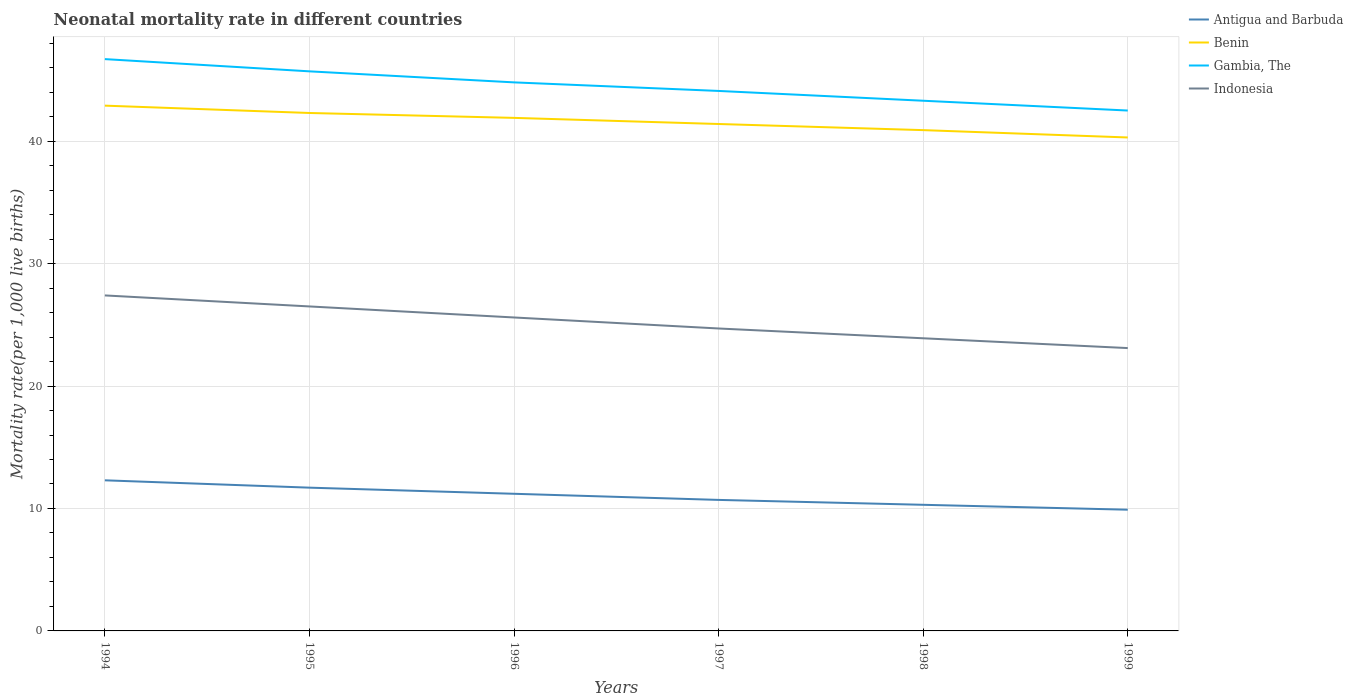Does the line corresponding to Benin intersect with the line corresponding to Antigua and Barbuda?
Your response must be concise. No. Is the number of lines equal to the number of legend labels?
Make the answer very short. Yes. Across all years, what is the maximum neonatal mortality rate in Gambia, The?
Offer a very short reply. 42.5. What is the total neonatal mortality rate in Antigua and Barbuda in the graph?
Ensure brevity in your answer.  1.3. What is the difference between the highest and the second highest neonatal mortality rate in Antigua and Barbuda?
Offer a very short reply. 2.4. How many lines are there?
Your answer should be compact. 4. How many years are there in the graph?
Give a very brief answer. 6. Does the graph contain any zero values?
Provide a succinct answer. No. Where does the legend appear in the graph?
Provide a short and direct response. Top right. How are the legend labels stacked?
Your response must be concise. Vertical. What is the title of the graph?
Offer a terse response. Neonatal mortality rate in different countries. What is the label or title of the Y-axis?
Your answer should be very brief. Mortality rate(per 1,0 live births). What is the Mortality rate(per 1,000 live births) in Antigua and Barbuda in 1994?
Keep it short and to the point. 12.3. What is the Mortality rate(per 1,000 live births) in Benin in 1994?
Make the answer very short. 42.9. What is the Mortality rate(per 1,000 live births) of Gambia, The in 1994?
Offer a terse response. 46.7. What is the Mortality rate(per 1,000 live births) in Indonesia in 1994?
Your response must be concise. 27.4. What is the Mortality rate(per 1,000 live births) of Antigua and Barbuda in 1995?
Provide a succinct answer. 11.7. What is the Mortality rate(per 1,000 live births) in Benin in 1995?
Provide a succinct answer. 42.3. What is the Mortality rate(per 1,000 live births) of Gambia, The in 1995?
Keep it short and to the point. 45.7. What is the Mortality rate(per 1,000 live births) of Benin in 1996?
Your answer should be compact. 41.9. What is the Mortality rate(per 1,000 live births) of Gambia, The in 1996?
Offer a very short reply. 44.8. What is the Mortality rate(per 1,000 live births) of Indonesia in 1996?
Provide a succinct answer. 25.6. What is the Mortality rate(per 1,000 live births) in Antigua and Barbuda in 1997?
Offer a terse response. 10.7. What is the Mortality rate(per 1,000 live births) of Benin in 1997?
Provide a short and direct response. 41.4. What is the Mortality rate(per 1,000 live births) of Gambia, The in 1997?
Your answer should be very brief. 44.1. What is the Mortality rate(per 1,000 live births) in Indonesia in 1997?
Your answer should be very brief. 24.7. What is the Mortality rate(per 1,000 live births) in Benin in 1998?
Your answer should be compact. 40.9. What is the Mortality rate(per 1,000 live births) in Gambia, The in 1998?
Your answer should be compact. 43.3. What is the Mortality rate(per 1,000 live births) in Indonesia in 1998?
Keep it short and to the point. 23.9. What is the Mortality rate(per 1,000 live births) in Benin in 1999?
Your response must be concise. 40.3. What is the Mortality rate(per 1,000 live births) in Gambia, The in 1999?
Your answer should be compact. 42.5. What is the Mortality rate(per 1,000 live births) in Indonesia in 1999?
Make the answer very short. 23.1. Across all years, what is the maximum Mortality rate(per 1,000 live births) of Benin?
Provide a succinct answer. 42.9. Across all years, what is the maximum Mortality rate(per 1,000 live births) of Gambia, The?
Offer a terse response. 46.7. Across all years, what is the maximum Mortality rate(per 1,000 live births) of Indonesia?
Give a very brief answer. 27.4. Across all years, what is the minimum Mortality rate(per 1,000 live births) in Benin?
Offer a terse response. 40.3. Across all years, what is the minimum Mortality rate(per 1,000 live births) of Gambia, The?
Ensure brevity in your answer.  42.5. Across all years, what is the minimum Mortality rate(per 1,000 live births) in Indonesia?
Provide a short and direct response. 23.1. What is the total Mortality rate(per 1,000 live births) of Antigua and Barbuda in the graph?
Make the answer very short. 66.1. What is the total Mortality rate(per 1,000 live births) of Benin in the graph?
Make the answer very short. 249.7. What is the total Mortality rate(per 1,000 live births) of Gambia, The in the graph?
Offer a terse response. 267.1. What is the total Mortality rate(per 1,000 live births) of Indonesia in the graph?
Ensure brevity in your answer.  151.2. What is the difference between the Mortality rate(per 1,000 live births) in Benin in 1994 and that in 1995?
Ensure brevity in your answer.  0.6. What is the difference between the Mortality rate(per 1,000 live births) in Indonesia in 1994 and that in 1996?
Your answer should be very brief. 1.8. What is the difference between the Mortality rate(per 1,000 live births) in Indonesia in 1994 and that in 1997?
Your response must be concise. 2.7. What is the difference between the Mortality rate(per 1,000 live births) in Antigua and Barbuda in 1994 and that in 1998?
Your answer should be very brief. 2. What is the difference between the Mortality rate(per 1,000 live births) in Indonesia in 1994 and that in 1998?
Keep it short and to the point. 3.5. What is the difference between the Mortality rate(per 1,000 live births) in Benin in 1994 and that in 1999?
Offer a terse response. 2.6. What is the difference between the Mortality rate(per 1,000 live births) in Gambia, The in 1994 and that in 1999?
Ensure brevity in your answer.  4.2. What is the difference between the Mortality rate(per 1,000 live births) of Benin in 1995 and that in 1996?
Provide a short and direct response. 0.4. What is the difference between the Mortality rate(per 1,000 live births) in Gambia, The in 1995 and that in 1996?
Your answer should be compact. 0.9. What is the difference between the Mortality rate(per 1,000 live births) in Antigua and Barbuda in 1995 and that in 1997?
Keep it short and to the point. 1. What is the difference between the Mortality rate(per 1,000 live births) in Indonesia in 1995 and that in 1998?
Offer a terse response. 2.6. What is the difference between the Mortality rate(per 1,000 live births) in Gambia, The in 1995 and that in 1999?
Give a very brief answer. 3.2. What is the difference between the Mortality rate(per 1,000 live births) in Indonesia in 1995 and that in 1999?
Provide a short and direct response. 3.4. What is the difference between the Mortality rate(per 1,000 live births) in Antigua and Barbuda in 1996 and that in 1997?
Your response must be concise. 0.5. What is the difference between the Mortality rate(per 1,000 live births) of Benin in 1996 and that in 1997?
Make the answer very short. 0.5. What is the difference between the Mortality rate(per 1,000 live births) in Indonesia in 1996 and that in 1997?
Give a very brief answer. 0.9. What is the difference between the Mortality rate(per 1,000 live births) in Antigua and Barbuda in 1996 and that in 1998?
Offer a terse response. 0.9. What is the difference between the Mortality rate(per 1,000 live births) in Benin in 1996 and that in 1998?
Your answer should be compact. 1. What is the difference between the Mortality rate(per 1,000 live births) in Indonesia in 1996 and that in 1998?
Provide a short and direct response. 1.7. What is the difference between the Mortality rate(per 1,000 live births) of Benin in 1996 and that in 1999?
Give a very brief answer. 1.6. What is the difference between the Mortality rate(per 1,000 live births) in Indonesia in 1996 and that in 1999?
Offer a terse response. 2.5. What is the difference between the Mortality rate(per 1,000 live births) in Indonesia in 1997 and that in 1998?
Make the answer very short. 0.8. What is the difference between the Mortality rate(per 1,000 live births) of Antigua and Barbuda in 1997 and that in 1999?
Make the answer very short. 0.8. What is the difference between the Mortality rate(per 1,000 live births) of Benin in 1997 and that in 1999?
Ensure brevity in your answer.  1.1. What is the difference between the Mortality rate(per 1,000 live births) in Gambia, The in 1997 and that in 1999?
Provide a succinct answer. 1.6. What is the difference between the Mortality rate(per 1,000 live births) of Indonesia in 1997 and that in 1999?
Offer a terse response. 1.6. What is the difference between the Mortality rate(per 1,000 live births) in Benin in 1998 and that in 1999?
Provide a short and direct response. 0.6. What is the difference between the Mortality rate(per 1,000 live births) of Gambia, The in 1998 and that in 1999?
Offer a very short reply. 0.8. What is the difference between the Mortality rate(per 1,000 live births) in Indonesia in 1998 and that in 1999?
Your answer should be very brief. 0.8. What is the difference between the Mortality rate(per 1,000 live births) of Antigua and Barbuda in 1994 and the Mortality rate(per 1,000 live births) of Benin in 1995?
Offer a very short reply. -30. What is the difference between the Mortality rate(per 1,000 live births) in Antigua and Barbuda in 1994 and the Mortality rate(per 1,000 live births) in Gambia, The in 1995?
Your answer should be very brief. -33.4. What is the difference between the Mortality rate(per 1,000 live births) of Antigua and Barbuda in 1994 and the Mortality rate(per 1,000 live births) of Indonesia in 1995?
Provide a short and direct response. -14.2. What is the difference between the Mortality rate(per 1,000 live births) of Benin in 1994 and the Mortality rate(per 1,000 live births) of Indonesia in 1995?
Your response must be concise. 16.4. What is the difference between the Mortality rate(per 1,000 live births) in Gambia, The in 1994 and the Mortality rate(per 1,000 live births) in Indonesia in 1995?
Your response must be concise. 20.2. What is the difference between the Mortality rate(per 1,000 live births) of Antigua and Barbuda in 1994 and the Mortality rate(per 1,000 live births) of Benin in 1996?
Make the answer very short. -29.6. What is the difference between the Mortality rate(per 1,000 live births) in Antigua and Barbuda in 1994 and the Mortality rate(per 1,000 live births) in Gambia, The in 1996?
Offer a very short reply. -32.5. What is the difference between the Mortality rate(per 1,000 live births) of Antigua and Barbuda in 1994 and the Mortality rate(per 1,000 live births) of Indonesia in 1996?
Your response must be concise. -13.3. What is the difference between the Mortality rate(per 1,000 live births) of Benin in 1994 and the Mortality rate(per 1,000 live births) of Gambia, The in 1996?
Your answer should be very brief. -1.9. What is the difference between the Mortality rate(per 1,000 live births) in Benin in 1994 and the Mortality rate(per 1,000 live births) in Indonesia in 1996?
Provide a succinct answer. 17.3. What is the difference between the Mortality rate(per 1,000 live births) in Gambia, The in 1994 and the Mortality rate(per 1,000 live births) in Indonesia in 1996?
Your answer should be very brief. 21.1. What is the difference between the Mortality rate(per 1,000 live births) of Antigua and Barbuda in 1994 and the Mortality rate(per 1,000 live births) of Benin in 1997?
Offer a very short reply. -29.1. What is the difference between the Mortality rate(per 1,000 live births) in Antigua and Barbuda in 1994 and the Mortality rate(per 1,000 live births) in Gambia, The in 1997?
Offer a terse response. -31.8. What is the difference between the Mortality rate(per 1,000 live births) in Antigua and Barbuda in 1994 and the Mortality rate(per 1,000 live births) in Indonesia in 1997?
Your answer should be very brief. -12.4. What is the difference between the Mortality rate(per 1,000 live births) of Benin in 1994 and the Mortality rate(per 1,000 live births) of Indonesia in 1997?
Provide a short and direct response. 18.2. What is the difference between the Mortality rate(per 1,000 live births) in Antigua and Barbuda in 1994 and the Mortality rate(per 1,000 live births) in Benin in 1998?
Make the answer very short. -28.6. What is the difference between the Mortality rate(per 1,000 live births) of Antigua and Barbuda in 1994 and the Mortality rate(per 1,000 live births) of Gambia, The in 1998?
Offer a very short reply. -31. What is the difference between the Mortality rate(per 1,000 live births) of Gambia, The in 1994 and the Mortality rate(per 1,000 live births) of Indonesia in 1998?
Keep it short and to the point. 22.8. What is the difference between the Mortality rate(per 1,000 live births) in Antigua and Barbuda in 1994 and the Mortality rate(per 1,000 live births) in Benin in 1999?
Ensure brevity in your answer.  -28. What is the difference between the Mortality rate(per 1,000 live births) in Antigua and Barbuda in 1994 and the Mortality rate(per 1,000 live births) in Gambia, The in 1999?
Your answer should be compact. -30.2. What is the difference between the Mortality rate(per 1,000 live births) of Antigua and Barbuda in 1994 and the Mortality rate(per 1,000 live births) of Indonesia in 1999?
Your answer should be compact. -10.8. What is the difference between the Mortality rate(per 1,000 live births) in Benin in 1994 and the Mortality rate(per 1,000 live births) in Indonesia in 1999?
Make the answer very short. 19.8. What is the difference between the Mortality rate(per 1,000 live births) in Gambia, The in 1994 and the Mortality rate(per 1,000 live births) in Indonesia in 1999?
Provide a short and direct response. 23.6. What is the difference between the Mortality rate(per 1,000 live births) in Antigua and Barbuda in 1995 and the Mortality rate(per 1,000 live births) in Benin in 1996?
Your response must be concise. -30.2. What is the difference between the Mortality rate(per 1,000 live births) in Antigua and Barbuda in 1995 and the Mortality rate(per 1,000 live births) in Gambia, The in 1996?
Ensure brevity in your answer.  -33.1. What is the difference between the Mortality rate(per 1,000 live births) in Benin in 1995 and the Mortality rate(per 1,000 live births) in Indonesia in 1996?
Ensure brevity in your answer.  16.7. What is the difference between the Mortality rate(per 1,000 live births) in Gambia, The in 1995 and the Mortality rate(per 1,000 live births) in Indonesia in 1996?
Offer a terse response. 20.1. What is the difference between the Mortality rate(per 1,000 live births) of Antigua and Barbuda in 1995 and the Mortality rate(per 1,000 live births) of Benin in 1997?
Ensure brevity in your answer.  -29.7. What is the difference between the Mortality rate(per 1,000 live births) of Antigua and Barbuda in 1995 and the Mortality rate(per 1,000 live births) of Gambia, The in 1997?
Your answer should be very brief. -32.4. What is the difference between the Mortality rate(per 1,000 live births) of Antigua and Barbuda in 1995 and the Mortality rate(per 1,000 live births) of Indonesia in 1997?
Offer a very short reply. -13. What is the difference between the Mortality rate(per 1,000 live births) in Benin in 1995 and the Mortality rate(per 1,000 live births) in Gambia, The in 1997?
Your response must be concise. -1.8. What is the difference between the Mortality rate(per 1,000 live births) in Benin in 1995 and the Mortality rate(per 1,000 live births) in Indonesia in 1997?
Your answer should be very brief. 17.6. What is the difference between the Mortality rate(per 1,000 live births) in Antigua and Barbuda in 1995 and the Mortality rate(per 1,000 live births) in Benin in 1998?
Provide a succinct answer. -29.2. What is the difference between the Mortality rate(per 1,000 live births) of Antigua and Barbuda in 1995 and the Mortality rate(per 1,000 live births) of Gambia, The in 1998?
Ensure brevity in your answer.  -31.6. What is the difference between the Mortality rate(per 1,000 live births) in Benin in 1995 and the Mortality rate(per 1,000 live births) in Gambia, The in 1998?
Your answer should be very brief. -1. What is the difference between the Mortality rate(per 1,000 live births) in Gambia, The in 1995 and the Mortality rate(per 1,000 live births) in Indonesia in 1998?
Provide a short and direct response. 21.8. What is the difference between the Mortality rate(per 1,000 live births) of Antigua and Barbuda in 1995 and the Mortality rate(per 1,000 live births) of Benin in 1999?
Provide a succinct answer. -28.6. What is the difference between the Mortality rate(per 1,000 live births) in Antigua and Barbuda in 1995 and the Mortality rate(per 1,000 live births) in Gambia, The in 1999?
Make the answer very short. -30.8. What is the difference between the Mortality rate(per 1,000 live births) in Antigua and Barbuda in 1995 and the Mortality rate(per 1,000 live births) in Indonesia in 1999?
Offer a terse response. -11.4. What is the difference between the Mortality rate(per 1,000 live births) in Benin in 1995 and the Mortality rate(per 1,000 live births) in Gambia, The in 1999?
Provide a succinct answer. -0.2. What is the difference between the Mortality rate(per 1,000 live births) in Gambia, The in 1995 and the Mortality rate(per 1,000 live births) in Indonesia in 1999?
Offer a very short reply. 22.6. What is the difference between the Mortality rate(per 1,000 live births) in Antigua and Barbuda in 1996 and the Mortality rate(per 1,000 live births) in Benin in 1997?
Offer a very short reply. -30.2. What is the difference between the Mortality rate(per 1,000 live births) of Antigua and Barbuda in 1996 and the Mortality rate(per 1,000 live births) of Gambia, The in 1997?
Offer a very short reply. -32.9. What is the difference between the Mortality rate(per 1,000 live births) in Benin in 1996 and the Mortality rate(per 1,000 live births) in Indonesia in 1997?
Provide a succinct answer. 17.2. What is the difference between the Mortality rate(per 1,000 live births) of Gambia, The in 1996 and the Mortality rate(per 1,000 live births) of Indonesia in 1997?
Your answer should be very brief. 20.1. What is the difference between the Mortality rate(per 1,000 live births) of Antigua and Barbuda in 1996 and the Mortality rate(per 1,000 live births) of Benin in 1998?
Make the answer very short. -29.7. What is the difference between the Mortality rate(per 1,000 live births) of Antigua and Barbuda in 1996 and the Mortality rate(per 1,000 live births) of Gambia, The in 1998?
Give a very brief answer. -32.1. What is the difference between the Mortality rate(per 1,000 live births) of Antigua and Barbuda in 1996 and the Mortality rate(per 1,000 live births) of Indonesia in 1998?
Offer a terse response. -12.7. What is the difference between the Mortality rate(per 1,000 live births) of Benin in 1996 and the Mortality rate(per 1,000 live births) of Gambia, The in 1998?
Your answer should be very brief. -1.4. What is the difference between the Mortality rate(per 1,000 live births) of Benin in 1996 and the Mortality rate(per 1,000 live births) of Indonesia in 1998?
Your response must be concise. 18. What is the difference between the Mortality rate(per 1,000 live births) of Gambia, The in 1996 and the Mortality rate(per 1,000 live births) of Indonesia in 1998?
Your answer should be compact. 20.9. What is the difference between the Mortality rate(per 1,000 live births) in Antigua and Barbuda in 1996 and the Mortality rate(per 1,000 live births) in Benin in 1999?
Ensure brevity in your answer.  -29.1. What is the difference between the Mortality rate(per 1,000 live births) of Antigua and Barbuda in 1996 and the Mortality rate(per 1,000 live births) of Gambia, The in 1999?
Your answer should be very brief. -31.3. What is the difference between the Mortality rate(per 1,000 live births) of Antigua and Barbuda in 1996 and the Mortality rate(per 1,000 live births) of Indonesia in 1999?
Provide a succinct answer. -11.9. What is the difference between the Mortality rate(per 1,000 live births) of Gambia, The in 1996 and the Mortality rate(per 1,000 live births) of Indonesia in 1999?
Keep it short and to the point. 21.7. What is the difference between the Mortality rate(per 1,000 live births) of Antigua and Barbuda in 1997 and the Mortality rate(per 1,000 live births) of Benin in 1998?
Provide a succinct answer. -30.2. What is the difference between the Mortality rate(per 1,000 live births) in Antigua and Barbuda in 1997 and the Mortality rate(per 1,000 live births) in Gambia, The in 1998?
Your response must be concise. -32.6. What is the difference between the Mortality rate(per 1,000 live births) in Antigua and Barbuda in 1997 and the Mortality rate(per 1,000 live births) in Indonesia in 1998?
Your response must be concise. -13.2. What is the difference between the Mortality rate(per 1,000 live births) of Benin in 1997 and the Mortality rate(per 1,000 live births) of Indonesia in 1998?
Your response must be concise. 17.5. What is the difference between the Mortality rate(per 1,000 live births) in Gambia, The in 1997 and the Mortality rate(per 1,000 live births) in Indonesia in 1998?
Offer a very short reply. 20.2. What is the difference between the Mortality rate(per 1,000 live births) in Antigua and Barbuda in 1997 and the Mortality rate(per 1,000 live births) in Benin in 1999?
Provide a succinct answer. -29.6. What is the difference between the Mortality rate(per 1,000 live births) of Antigua and Barbuda in 1997 and the Mortality rate(per 1,000 live births) of Gambia, The in 1999?
Give a very brief answer. -31.8. What is the difference between the Mortality rate(per 1,000 live births) in Benin in 1997 and the Mortality rate(per 1,000 live births) in Gambia, The in 1999?
Your response must be concise. -1.1. What is the difference between the Mortality rate(per 1,000 live births) in Benin in 1997 and the Mortality rate(per 1,000 live births) in Indonesia in 1999?
Ensure brevity in your answer.  18.3. What is the difference between the Mortality rate(per 1,000 live births) of Gambia, The in 1997 and the Mortality rate(per 1,000 live births) of Indonesia in 1999?
Provide a succinct answer. 21. What is the difference between the Mortality rate(per 1,000 live births) of Antigua and Barbuda in 1998 and the Mortality rate(per 1,000 live births) of Benin in 1999?
Your answer should be very brief. -30. What is the difference between the Mortality rate(per 1,000 live births) of Antigua and Barbuda in 1998 and the Mortality rate(per 1,000 live births) of Gambia, The in 1999?
Make the answer very short. -32.2. What is the difference between the Mortality rate(per 1,000 live births) of Antigua and Barbuda in 1998 and the Mortality rate(per 1,000 live births) of Indonesia in 1999?
Provide a succinct answer. -12.8. What is the difference between the Mortality rate(per 1,000 live births) of Benin in 1998 and the Mortality rate(per 1,000 live births) of Indonesia in 1999?
Give a very brief answer. 17.8. What is the difference between the Mortality rate(per 1,000 live births) of Gambia, The in 1998 and the Mortality rate(per 1,000 live births) of Indonesia in 1999?
Your answer should be compact. 20.2. What is the average Mortality rate(per 1,000 live births) of Antigua and Barbuda per year?
Provide a short and direct response. 11.02. What is the average Mortality rate(per 1,000 live births) in Benin per year?
Offer a terse response. 41.62. What is the average Mortality rate(per 1,000 live births) of Gambia, The per year?
Your response must be concise. 44.52. What is the average Mortality rate(per 1,000 live births) of Indonesia per year?
Ensure brevity in your answer.  25.2. In the year 1994, what is the difference between the Mortality rate(per 1,000 live births) in Antigua and Barbuda and Mortality rate(per 1,000 live births) in Benin?
Give a very brief answer. -30.6. In the year 1994, what is the difference between the Mortality rate(per 1,000 live births) in Antigua and Barbuda and Mortality rate(per 1,000 live births) in Gambia, The?
Offer a terse response. -34.4. In the year 1994, what is the difference between the Mortality rate(per 1,000 live births) of Antigua and Barbuda and Mortality rate(per 1,000 live births) of Indonesia?
Ensure brevity in your answer.  -15.1. In the year 1994, what is the difference between the Mortality rate(per 1,000 live births) of Benin and Mortality rate(per 1,000 live births) of Indonesia?
Provide a short and direct response. 15.5. In the year 1994, what is the difference between the Mortality rate(per 1,000 live births) in Gambia, The and Mortality rate(per 1,000 live births) in Indonesia?
Offer a very short reply. 19.3. In the year 1995, what is the difference between the Mortality rate(per 1,000 live births) of Antigua and Barbuda and Mortality rate(per 1,000 live births) of Benin?
Make the answer very short. -30.6. In the year 1995, what is the difference between the Mortality rate(per 1,000 live births) of Antigua and Barbuda and Mortality rate(per 1,000 live births) of Gambia, The?
Provide a short and direct response. -34. In the year 1995, what is the difference between the Mortality rate(per 1,000 live births) of Antigua and Barbuda and Mortality rate(per 1,000 live births) of Indonesia?
Offer a very short reply. -14.8. In the year 1995, what is the difference between the Mortality rate(per 1,000 live births) of Gambia, The and Mortality rate(per 1,000 live births) of Indonesia?
Ensure brevity in your answer.  19.2. In the year 1996, what is the difference between the Mortality rate(per 1,000 live births) in Antigua and Barbuda and Mortality rate(per 1,000 live births) in Benin?
Offer a terse response. -30.7. In the year 1996, what is the difference between the Mortality rate(per 1,000 live births) of Antigua and Barbuda and Mortality rate(per 1,000 live births) of Gambia, The?
Offer a very short reply. -33.6. In the year 1996, what is the difference between the Mortality rate(per 1,000 live births) in Antigua and Barbuda and Mortality rate(per 1,000 live births) in Indonesia?
Ensure brevity in your answer.  -14.4. In the year 1996, what is the difference between the Mortality rate(per 1,000 live births) in Benin and Mortality rate(per 1,000 live births) in Gambia, The?
Your response must be concise. -2.9. In the year 1996, what is the difference between the Mortality rate(per 1,000 live births) in Benin and Mortality rate(per 1,000 live births) in Indonesia?
Make the answer very short. 16.3. In the year 1997, what is the difference between the Mortality rate(per 1,000 live births) of Antigua and Barbuda and Mortality rate(per 1,000 live births) of Benin?
Offer a very short reply. -30.7. In the year 1997, what is the difference between the Mortality rate(per 1,000 live births) in Antigua and Barbuda and Mortality rate(per 1,000 live births) in Gambia, The?
Offer a very short reply. -33.4. In the year 1997, what is the difference between the Mortality rate(per 1,000 live births) in Benin and Mortality rate(per 1,000 live births) in Gambia, The?
Offer a very short reply. -2.7. In the year 1998, what is the difference between the Mortality rate(per 1,000 live births) of Antigua and Barbuda and Mortality rate(per 1,000 live births) of Benin?
Offer a very short reply. -30.6. In the year 1998, what is the difference between the Mortality rate(per 1,000 live births) of Antigua and Barbuda and Mortality rate(per 1,000 live births) of Gambia, The?
Make the answer very short. -33. In the year 1998, what is the difference between the Mortality rate(per 1,000 live births) of Antigua and Barbuda and Mortality rate(per 1,000 live births) of Indonesia?
Ensure brevity in your answer.  -13.6. In the year 1999, what is the difference between the Mortality rate(per 1,000 live births) of Antigua and Barbuda and Mortality rate(per 1,000 live births) of Benin?
Offer a terse response. -30.4. In the year 1999, what is the difference between the Mortality rate(per 1,000 live births) in Antigua and Barbuda and Mortality rate(per 1,000 live births) in Gambia, The?
Give a very brief answer. -32.6. In the year 1999, what is the difference between the Mortality rate(per 1,000 live births) of Antigua and Barbuda and Mortality rate(per 1,000 live births) of Indonesia?
Keep it short and to the point. -13.2. In the year 1999, what is the difference between the Mortality rate(per 1,000 live births) in Benin and Mortality rate(per 1,000 live births) in Gambia, The?
Offer a terse response. -2.2. In the year 1999, what is the difference between the Mortality rate(per 1,000 live births) of Gambia, The and Mortality rate(per 1,000 live births) of Indonesia?
Provide a succinct answer. 19.4. What is the ratio of the Mortality rate(per 1,000 live births) of Antigua and Barbuda in 1994 to that in 1995?
Your response must be concise. 1.05. What is the ratio of the Mortality rate(per 1,000 live births) of Benin in 1994 to that in 1995?
Your answer should be very brief. 1.01. What is the ratio of the Mortality rate(per 1,000 live births) in Gambia, The in 1994 to that in 1995?
Provide a succinct answer. 1.02. What is the ratio of the Mortality rate(per 1,000 live births) of Indonesia in 1994 to that in 1995?
Provide a succinct answer. 1.03. What is the ratio of the Mortality rate(per 1,000 live births) of Antigua and Barbuda in 1994 to that in 1996?
Your answer should be compact. 1.1. What is the ratio of the Mortality rate(per 1,000 live births) of Benin in 1994 to that in 1996?
Your response must be concise. 1.02. What is the ratio of the Mortality rate(per 1,000 live births) of Gambia, The in 1994 to that in 1996?
Offer a very short reply. 1.04. What is the ratio of the Mortality rate(per 1,000 live births) in Indonesia in 1994 to that in 1996?
Provide a succinct answer. 1.07. What is the ratio of the Mortality rate(per 1,000 live births) of Antigua and Barbuda in 1994 to that in 1997?
Provide a succinct answer. 1.15. What is the ratio of the Mortality rate(per 1,000 live births) of Benin in 1994 to that in 1997?
Offer a terse response. 1.04. What is the ratio of the Mortality rate(per 1,000 live births) in Gambia, The in 1994 to that in 1997?
Keep it short and to the point. 1.06. What is the ratio of the Mortality rate(per 1,000 live births) in Indonesia in 1994 to that in 1997?
Ensure brevity in your answer.  1.11. What is the ratio of the Mortality rate(per 1,000 live births) of Antigua and Barbuda in 1994 to that in 1998?
Give a very brief answer. 1.19. What is the ratio of the Mortality rate(per 1,000 live births) in Benin in 1994 to that in 1998?
Offer a terse response. 1.05. What is the ratio of the Mortality rate(per 1,000 live births) of Gambia, The in 1994 to that in 1998?
Ensure brevity in your answer.  1.08. What is the ratio of the Mortality rate(per 1,000 live births) of Indonesia in 1994 to that in 1998?
Offer a very short reply. 1.15. What is the ratio of the Mortality rate(per 1,000 live births) in Antigua and Barbuda in 1994 to that in 1999?
Ensure brevity in your answer.  1.24. What is the ratio of the Mortality rate(per 1,000 live births) of Benin in 1994 to that in 1999?
Ensure brevity in your answer.  1.06. What is the ratio of the Mortality rate(per 1,000 live births) of Gambia, The in 1994 to that in 1999?
Your response must be concise. 1.1. What is the ratio of the Mortality rate(per 1,000 live births) of Indonesia in 1994 to that in 1999?
Your response must be concise. 1.19. What is the ratio of the Mortality rate(per 1,000 live births) in Antigua and Barbuda in 1995 to that in 1996?
Your answer should be very brief. 1.04. What is the ratio of the Mortality rate(per 1,000 live births) of Benin in 1995 to that in 1996?
Keep it short and to the point. 1.01. What is the ratio of the Mortality rate(per 1,000 live births) in Gambia, The in 1995 to that in 1996?
Your answer should be compact. 1.02. What is the ratio of the Mortality rate(per 1,000 live births) of Indonesia in 1995 to that in 1996?
Ensure brevity in your answer.  1.04. What is the ratio of the Mortality rate(per 1,000 live births) in Antigua and Barbuda in 1995 to that in 1997?
Keep it short and to the point. 1.09. What is the ratio of the Mortality rate(per 1,000 live births) of Benin in 1995 to that in 1997?
Your response must be concise. 1.02. What is the ratio of the Mortality rate(per 1,000 live births) in Gambia, The in 1995 to that in 1997?
Offer a very short reply. 1.04. What is the ratio of the Mortality rate(per 1,000 live births) of Indonesia in 1995 to that in 1997?
Offer a terse response. 1.07. What is the ratio of the Mortality rate(per 1,000 live births) in Antigua and Barbuda in 1995 to that in 1998?
Give a very brief answer. 1.14. What is the ratio of the Mortality rate(per 1,000 live births) of Benin in 1995 to that in 1998?
Provide a short and direct response. 1.03. What is the ratio of the Mortality rate(per 1,000 live births) of Gambia, The in 1995 to that in 1998?
Offer a very short reply. 1.06. What is the ratio of the Mortality rate(per 1,000 live births) of Indonesia in 1995 to that in 1998?
Make the answer very short. 1.11. What is the ratio of the Mortality rate(per 1,000 live births) of Antigua and Barbuda in 1995 to that in 1999?
Offer a very short reply. 1.18. What is the ratio of the Mortality rate(per 1,000 live births) in Benin in 1995 to that in 1999?
Offer a terse response. 1.05. What is the ratio of the Mortality rate(per 1,000 live births) in Gambia, The in 1995 to that in 1999?
Ensure brevity in your answer.  1.08. What is the ratio of the Mortality rate(per 1,000 live births) in Indonesia in 1995 to that in 1999?
Your answer should be very brief. 1.15. What is the ratio of the Mortality rate(per 1,000 live births) in Antigua and Barbuda in 1996 to that in 1997?
Make the answer very short. 1.05. What is the ratio of the Mortality rate(per 1,000 live births) of Benin in 1996 to that in 1997?
Your response must be concise. 1.01. What is the ratio of the Mortality rate(per 1,000 live births) in Gambia, The in 1996 to that in 1997?
Your answer should be compact. 1.02. What is the ratio of the Mortality rate(per 1,000 live births) of Indonesia in 1996 to that in 1997?
Provide a succinct answer. 1.04. What is the ratio of the Mortality rate(per 1,000 live births) of Antigua and Barbuda in 1996 to that in 1998?
Make the answer very short. 1.09. What is the ratio of the Mortality rate(per 1,000 live births) in Benin in 1996 to that in 1998?
Make the answer very short. 1.02. What is the ratio of the Mortality rate(per 1,000 live births) in Gambia, The in 1996 to that in 1998?
Provide a short and direct response. 1.03. What is the ratio of the Mortality rate(per 1,000 live births) in Indonesia in 1996 to that in 1998?
Ensure brevity in your answer.  1.07. What is the ratio of the Mortality rate(per 1,000 live births) in Antigua and Barbuda in 1996 to that in 1999?
Give a very brief answer. 1.13. What is the ratio of the Mortality rate(per 1,000 live births) in Benin in 1996 to that in 1999?
Your answer should be very brief. 1.04. What is the ratio of the Mortality rate(per 1,000 live births) of Gambia, The in 1996 to that in 1999?
Make the answer very short. 1.05. What is the ratio of the Mortality rate(per 1,000 live births) of Indonesia in 1996 to that in 1999?
Offer a terse response. 1.11. What is the ratio of the Mortality rate(per 1,000 live births) of Antigua and Barbuda in 1997 to that in 1998?
Ensure brevity in your answer.  1.04. What is the ratio of the Mortality rate(per 1,000 live births) in Benin in 1997 to that in 1998?
Offer a terse response. 1.01. What is the ratio of the Mortality rate(per 1,000 live births) in Gambia, The in 1997 to that in 1998?
Ensure brevity in your answer.  1.02. What is the ratio of the Mortality rate(per 1,000 live births) of Indonesia in 1997 to that in 1998?
Offer a very short reply. 1.03. What is the ratio of the Mortality rate(per 1,000 live births) of Antigua and Barbuda in 1997 to that in 1999?
Provide a succinct answer. 1.08. What is the ratio of the Mortality rate(per 1,000 live births) of Benin in 1997 to that in 1999?
Provide a short and direct response. 1.03. What is the ratio of the Mortality rate(per 1,000 live births) in Gambia, The in 1997 to that in 1999?
Your answer should be compact. 1.04. What is the ratio of the Mortality rate(per 1,000 live births) of Indonesia in 1997 to that in 1999?
Provide a short and direct response. 1.07. What is the ratio of the Mortality rate(per 1,000 live births) in Antigua and Barbuda in 1998 to that in 1999?
Keep it short and to the point. 1.04. What is the ratio of the Mortality rate(per 1,000 live births) of Benin in 1998 to that in 1999?
Provide a succinct answer. 1.01. What is the ratio of the Mortality rate(per 1,000 live births) in Gambia, The in 1998 to that in 1999?
Keep it short and to the point. 1.02. What is the ratio of the Mortality rate(per 1,000 live births) in Indonesia in 1998 to that in 1999?
Offer a terse response. 1.03. What is the difference between the highest and the second highest Mortality rate(per 1,000 live births) of Antigua and Barbuda?
Give a very brief answer. 0.6. What is the difference between the highest and the second highest Mortality rate(per 1,000 live births) in Gambia, The?
Your answer should be very brief. 1. What is the difference between the highest and the second highest Mortality rate(per 1,000 live births) of Indonesia?
Provide a succinct answer. 0.9. What is the difference between the highest and the lowest Mortality rate(per 1,000 live births) in Antigua and Barbuda?
Give a very brief answer. 2.4. What is the difference between the highest and the lowest Mortality rate(per 1,000 live births) in Indonesia?
Offer a very short reply. 4.3. 